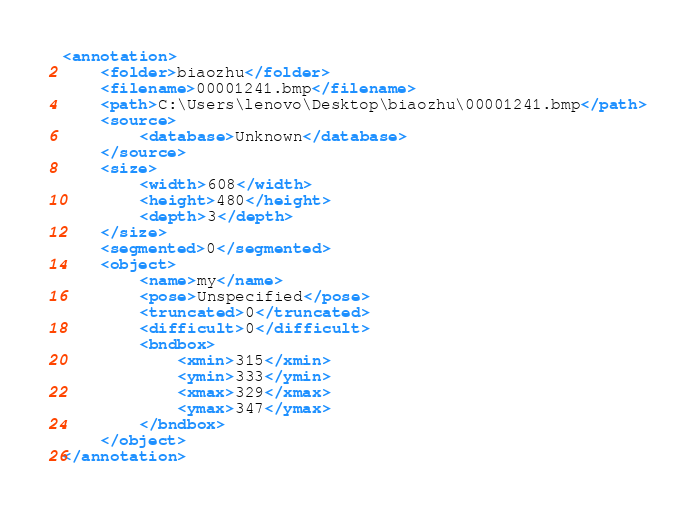Convert code to text. <code><loc_0><loc_0><loc_500><loc_500><_XML_><annotation>
	<folder>biaozhu</folder>
	<filename>00001241.bmp</filename>
	<path>C:\Users\lenovo\Desktop\biaozhu\00001241.bmp</path>
	<source>
		<database>Unknown</database>
	</source>
	<size>
		<width>608</width>
		<height>480</height>
		<depth>3</depth>
	</size>
	<segmented>0</segmented>
	<object>
		<name>my</name>
		<pose>Unspecified</pose>
		<truncated>0</truncated>
		<difficult>0</difficult>
		<bndbox>
			<xmin>315</xmin>
			<ymin>333</ymin>
			<xmax>329</xmax>
			<ymax>347</ymax>
		</bndbox>
	</object>
</annotation>
</code> 